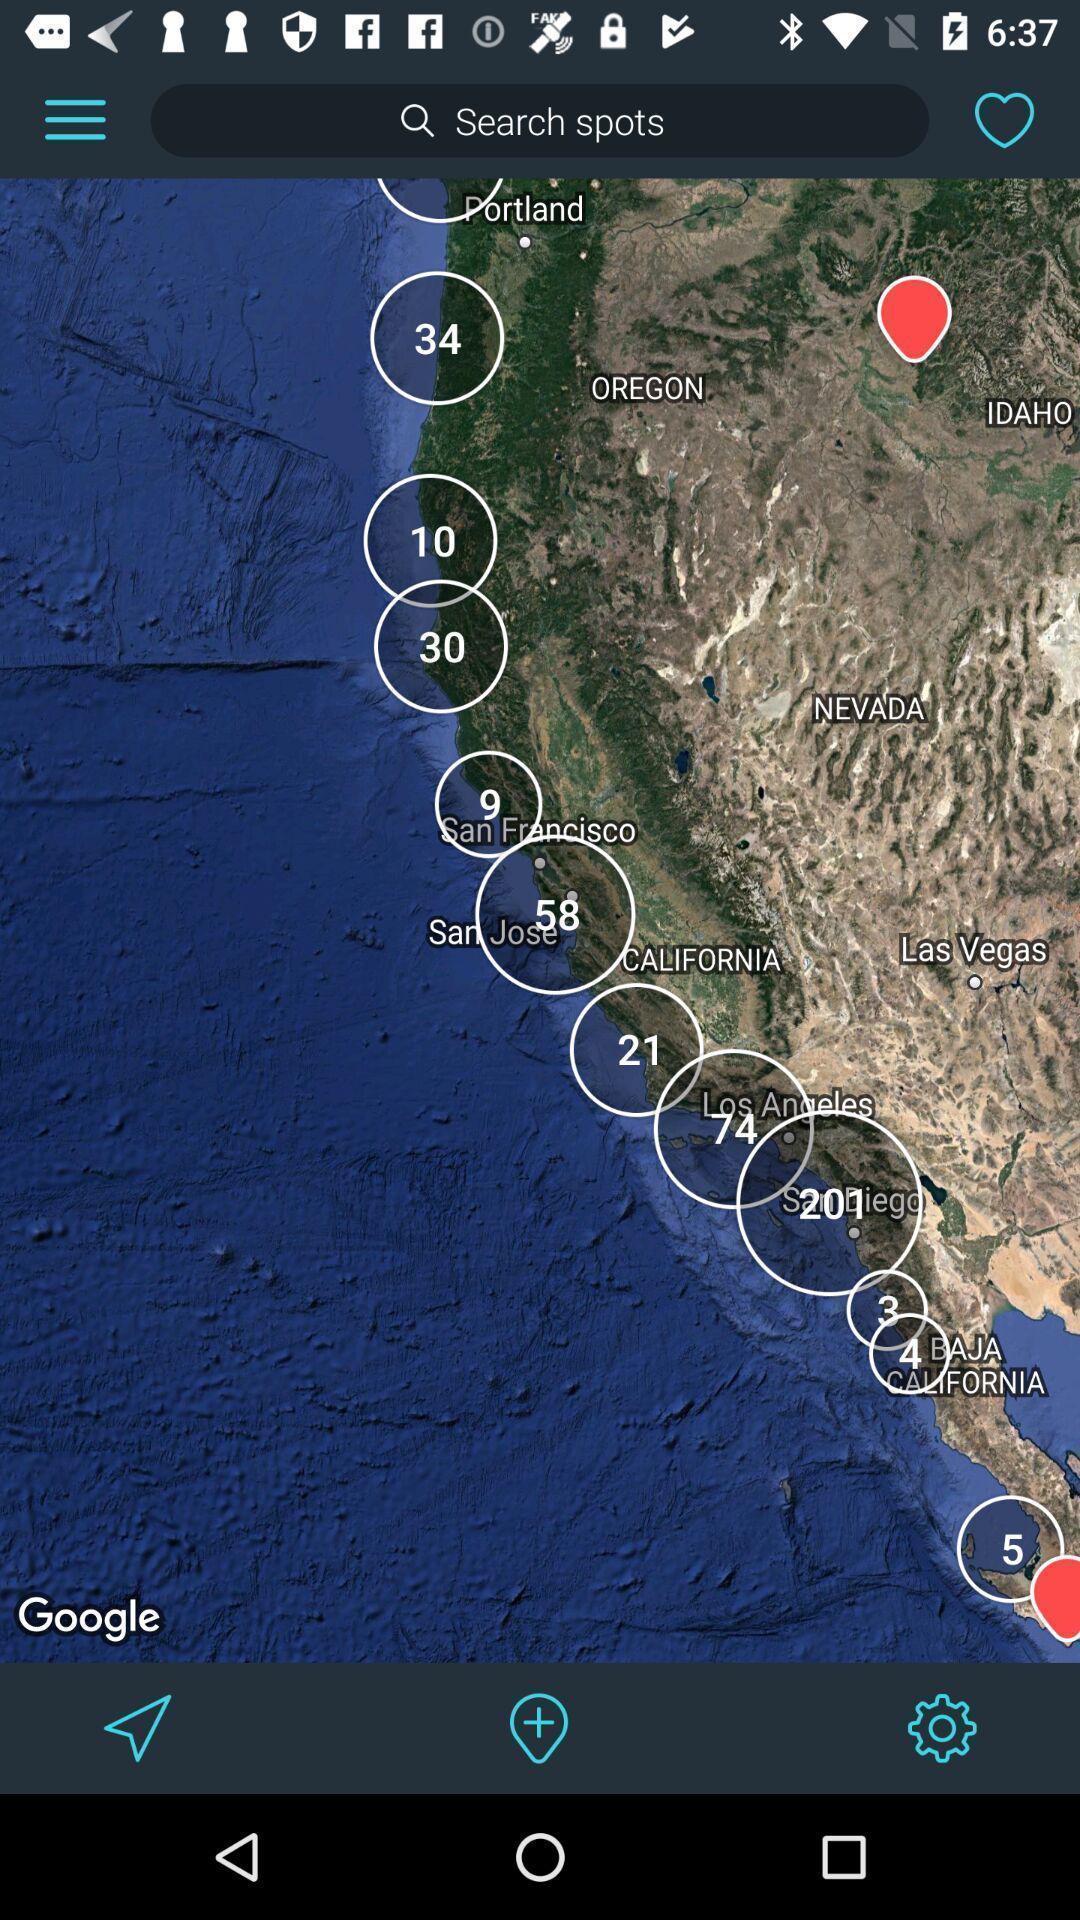Explain the elements present in this screenshot. Search page with available spots in the tour app. 